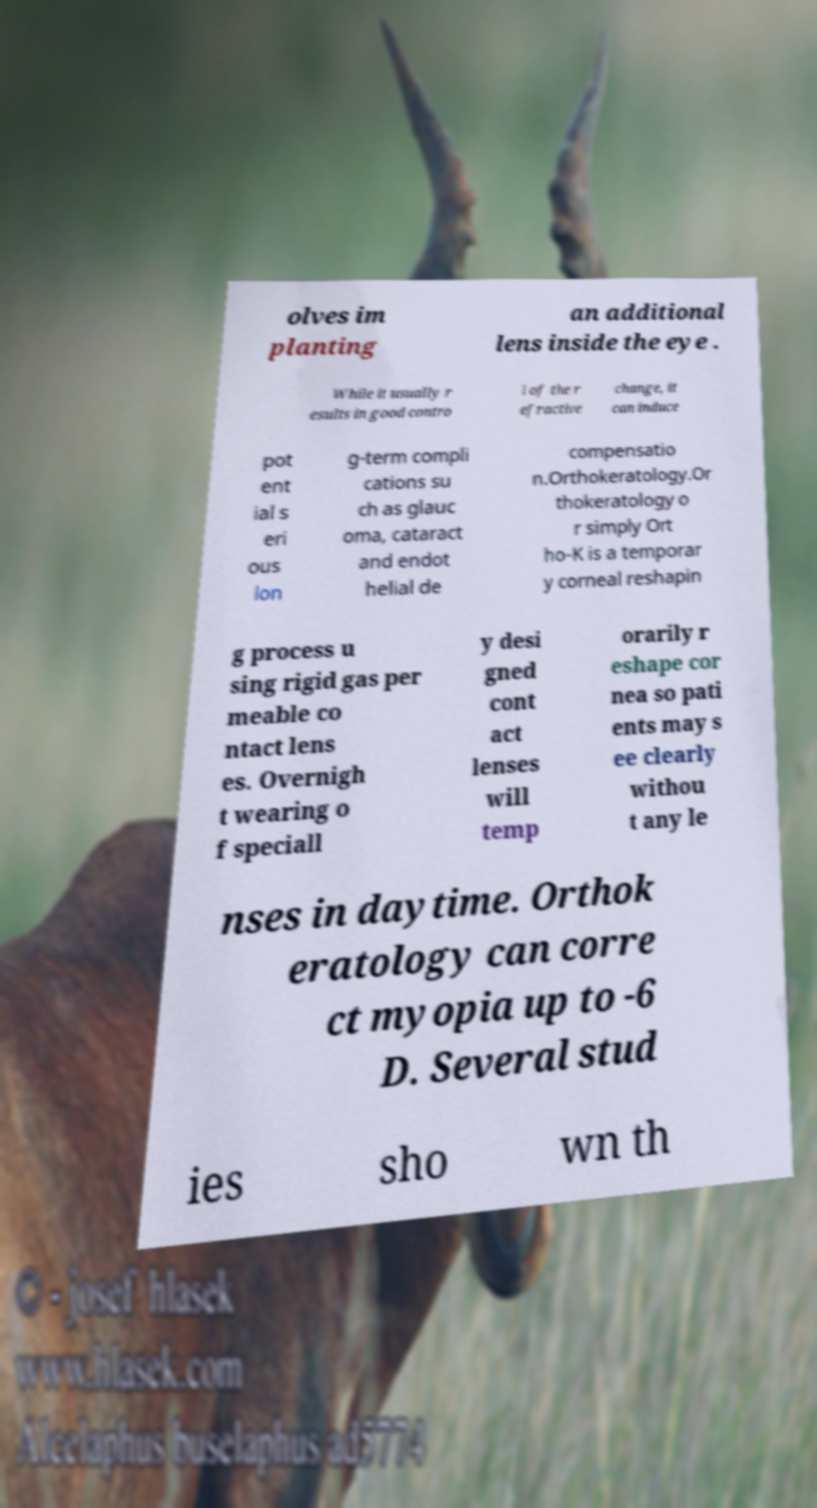There's text embedded in this image that I need extracted. Can you transcribe it verbatim? olves im planting an additional lens inside the eye . While it usually r esults in good contro l of the r efractive change, it can induce pot ent ial s eri ous lon g-term compli cations su ch as glauc oma, cataract and endot helial de compensatio n.Orthokeratology.Or thokeratology o r simply Ort ho-K is a temporar y corneal reshapin g process u sing rigid gas per meable co ntact lens es. Overnigh t wearing o f speciall y desi gned cont act lenses will temp orarily r eshape cor nea so pati ents may s ee clearly withou t any le nses in daytime. Orthok eratology can corre ct myopia up to -6 D. Several stud ies sho wn th 